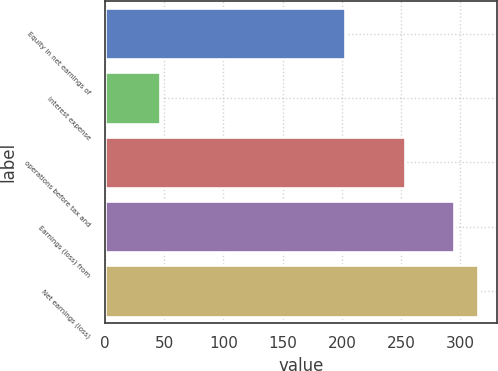Convert chart to OTSL. <chart><loc_0><loc_0><loc_500><loc_500><bar_chart><fcel>Equity in net earnings of<fcel>Interest expense<fcel>operations before tax and<fcel>Earnings (loss) from<fcel>Net earnings (loss)<nl><fcel>203<fcel>47<fcel>253<fcel>294.2<fcel>314.8<nl></chart> 